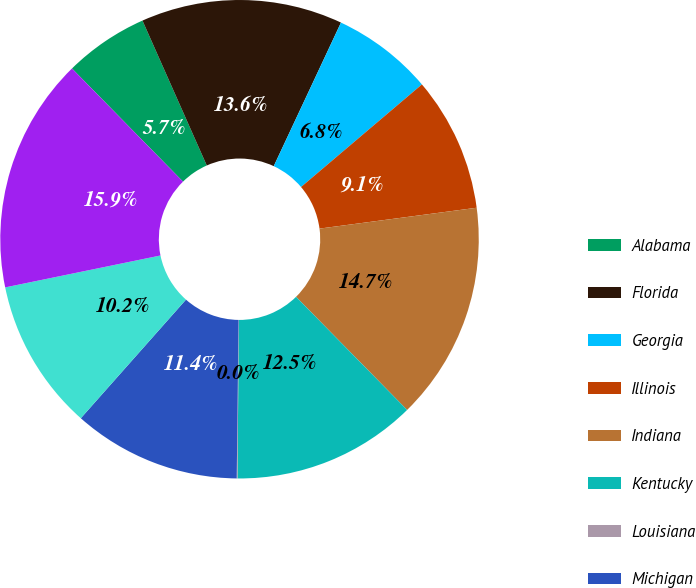<chart> <loc_0><loc_0><loc_500><loc_500><pie_chart><fcel>Alabama<fcel>Florida<fcel>Georgia<fcel>Illinois<fcel>Indiana<fcel>Kentucky<fcel>Louisiana<fcel>Michigan<fcel>North Carolina<fcel>Ohio<nl><fcel>5.7%<fcel>13.62%<fcel>6.83%<fcel>9.1%<fcel>14.75%<fcel>12.49%<fcel>0.05%<fcel>11.36%<fcel>10.23%<fcel>15.88%<nl></chart> 